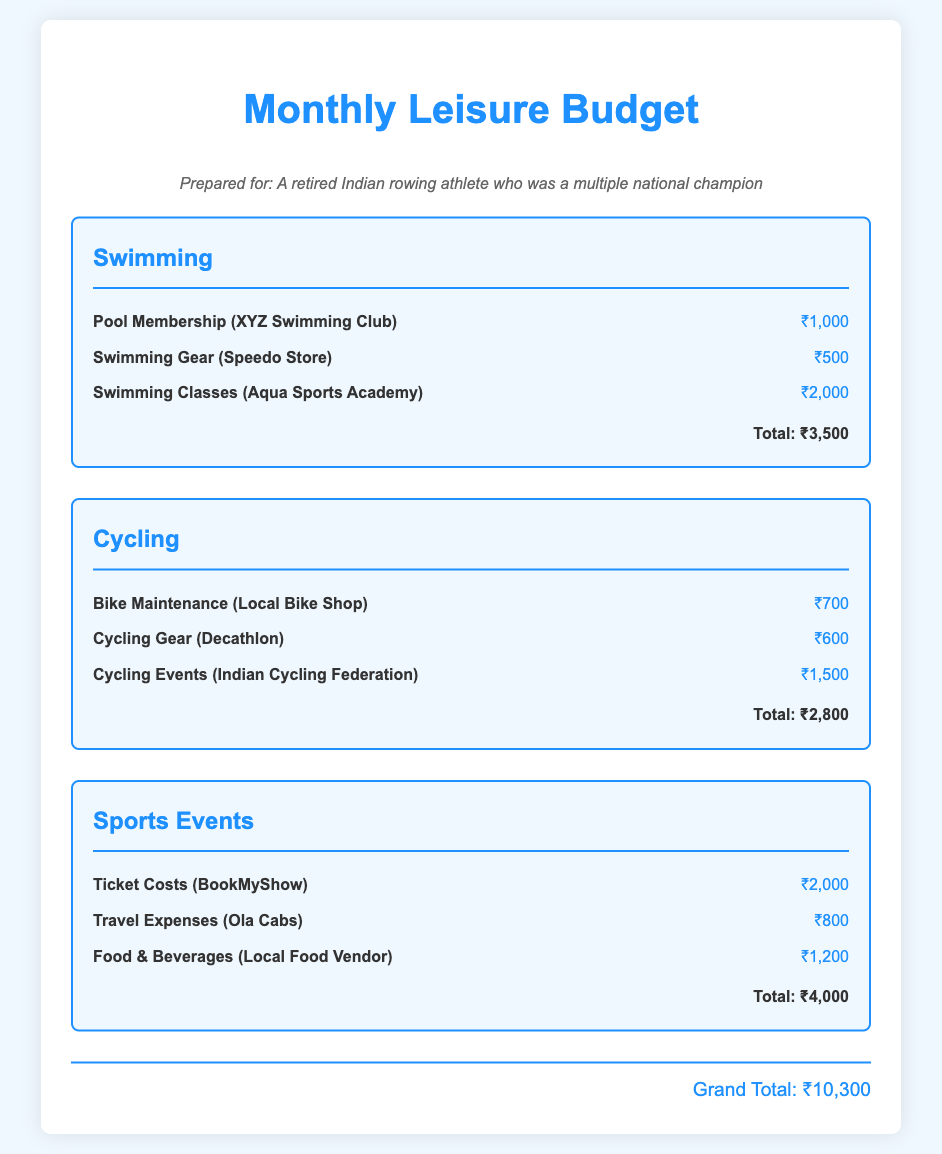What is the total expense for swimming? The total expense for swimming is listed under the swimming category, which adds up to ₹3,500.
Answer: ₹3,500 How much is the bike maintenance cost? The bike maintenance cost is detailed in the cycling category and it amounts to ₹700.
Answer: ₹700 What is the expense for ticket costs under sports events? The ticket costs are provided under the sports events category and are noted as ₹2,000.
Answer: ₹2,000 Which item has the highest expense in the swimming category? The highest expense in the swimming category is swimming classes at ₹2,000.
Answer: Swimming Classes (Aqua Sports Academy) What is the grand total of all expenses? The grand total is provided at the end of the document as the sum of all expenses, which is ₹10,300.
Answer: ₹10,300 How much is spent on food and beverages for sports events? The food and beverages cost is located under the sports events category and is ₹1,200.
Answer: ₹1,200 What is the total amount spent on cycling gear? The total amount spent on cycling gear is specified in the cycling category and it is ₹600.
Answer: ₹600 Which swimming gear store is listed in the budget? The swimming gear store mentioned is Speedo Store, which has an associated expense.
Answer: Speedo Store What are the total expenses for cycling activities? The total expenses for cycling activities are summarized under the cycling category, which adds up to ₹2,800.
Answer: ₹2,800 